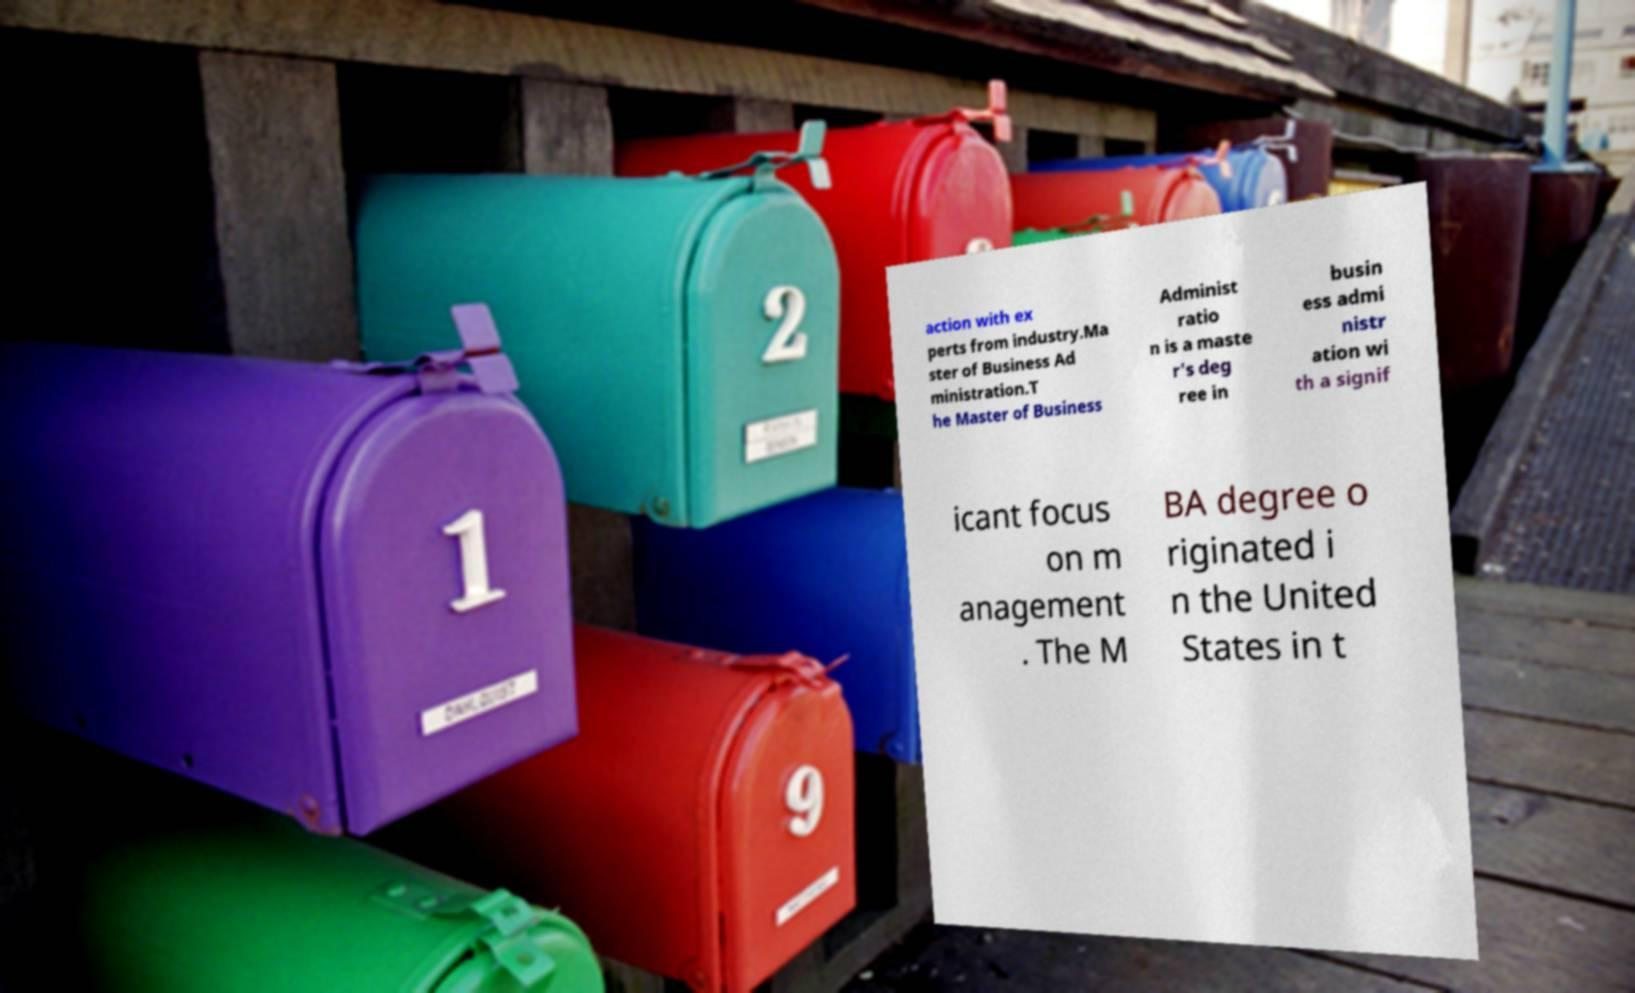Please identify and transcribe the text found in this image. action with ex perts from industry.Ma ster of Business Ad ministration.T he Master of Business Administ ratio n is a maste r's deg ree in busin ess admi nistr ation wi th a signif icant focus on m anagement . The M BA degree o riginated i n the United States in t 